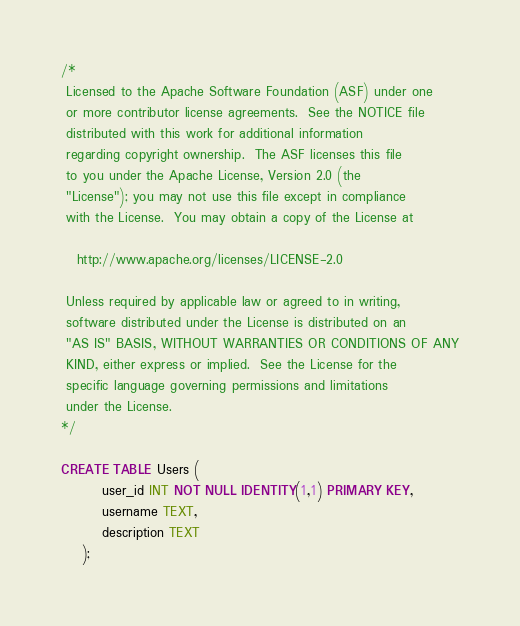<code> <loc_0><loc_0><loc_500><loc_500><_SQL_>/*
 Licensed to the Apache Software Foundation (ASF) under one
 or more contributor license agreements.  See the NOTICE file
 distributed with this work for additional information
 regarding copyright ownership.  The ASF licenses this file
 to you under the Apache License, Version 2.0 (the
 "License"); you may not use this file except in compliance
 with the License.  You may obtain a copy of the License at

   http://www.apache.org/licenses/LICENSE-2.0

 Unless required by applicable law or agreed to in writing,
 software distributed under the License is distributed on an
 "AS IS" BASIS, WITHOUT WARRANTIES OR CONDITIONS OF ANY
 KIND, either express or implied.  See the License for the
 specific language governing permissions and limitations
 under the License.
*/

CREATE TABLE Users (
        user_id INT NOT NULL IDENTITY(1,1) PRIMARY KEY,
        username TEXT,
        description TEXT
    );
</code> 